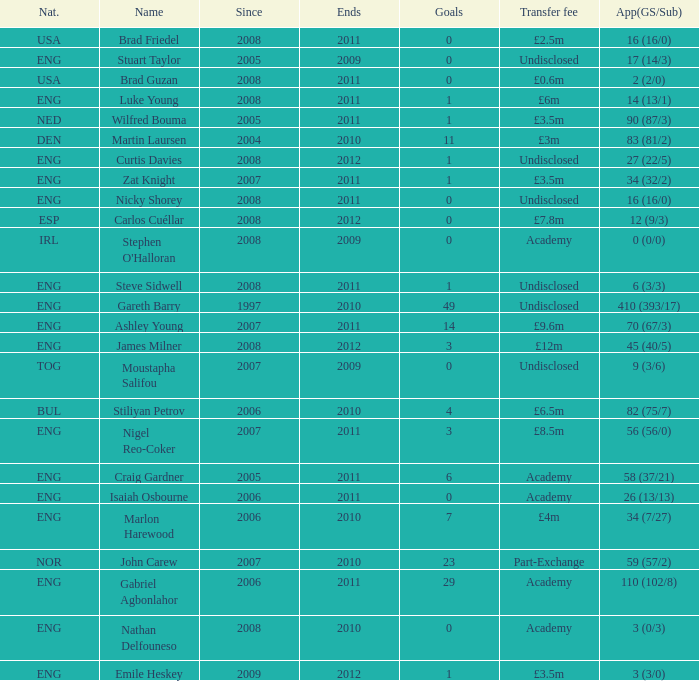I'm looking to parse the entire table for insights. Could you assist me with that? {'header': ['Nat.', 'Name', 'Since', 'Ends', 'Goals', 'Transfer fee', 'App(GS/Sub)'], 'rows': [['USA', 'Brad Friedel', '2008', '2011', '0', '£2.5m', '16 (16/0)'], ['ENG', 'Stuart Taylor', '2005', '2009', '0', 'Undisclosed', '17 (14/3)'], ['USA', 'Brad Guzan', '2008', '2011', '0', '£0.6m', '2 (2/0)'], ['ENG', 'Luke Young', '2008', '2011', '1', '£6m', '14 (13/1)'], ['NED', 'Wilfred Bouma', '2005', '2011', '1', '£3.5m', '90 (87/3)'], ['DEN', 'Martin Laursen', '2004', '2010', '11', '£3m', '83 (81/2)'], ['ENG', 'Curtis Davies', '2008', '2012', '1', 'Undisclosed', '27 (22/5)'], ['ENG', 'Zat Knight', '2007', '2011', '1', '£3.5m', '34 (32/2)'], ['ENG', 'Nicky Shorey', '2008', '2011', '0', 'Undisclosed', '16 (16/0)'], ['ESP', 'Carlos Cuéllar', '2008', '2012', '0', '£7.8m', '12 (9/3)'], ['IRL', "Stephen O'Halloran", '2008', '2009', '0', 'Academy', '0 (0/0)'], ['ENG', 'Steve Sidwell', '2008', '2011', '1', 'Undisclosed', '6 (3/3)'], ['ENG', 'Gareth Barry', '1997', '2010', '49', 'Undisclosed', '410 (393/17)'], ['ENG', 'Ashley Young', '2007', '2011', '14', '£9.6m', '70 (67/3)'], ['ENG', 'James Milner', '2008', '2012', '3', '£12m', '45 (40/5)'], ['TOG', 'Moustapha Salifou', '2007', '2009', '0', 'Undisclosed', '9 (3/6)'], ['BUL', 'Stiliyan Petrov', '2006', '2010', '4', '£6.5m', '82 (75/7)'], ['ENG', 'Nigel Reo-Coker', '2007', '2011', '3', '£8.5m', '56 (56/0)'], ['ENG', 'Craig Gardner', '2005', '2011', '6', 'Academy', '58 (37/21)'], ['ENG', 'Isaiah Osbourne', '2006', '2011', '0', 'Academy', '26 (13/13)'], ['ENG', 'Marlon Harewood', '2006', '2010', '7', '£4m', '34 (7/27)'], ['NOR', 'John Carew', '2007', '2010', '23', 'Part-Exchange', '59 (57/2)'], ['ENG', 'Gabriel Agbonlahor', '2006', '2011', '29', 'Academy', '110 (102/8)'], ['ENG', 'Nathan Delfouneso', '2008', '2010', '0', 'Academy', '3 (0/3)'], ['ENG', 'Emile Heskey', '2009', '2012', '1', '£3.5m', '3 (3/0)']]} When the transfer fee is £8.5m, what is the total ends? 2011.0. 